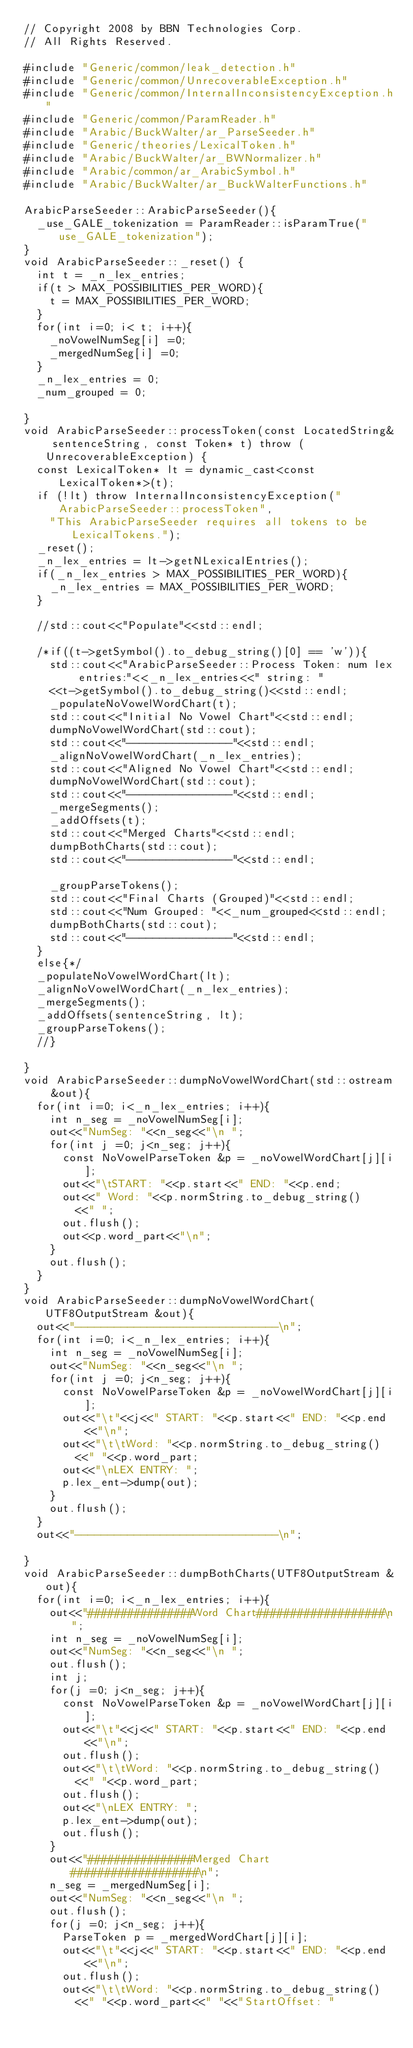<code> <loc_0><loc_0><loc_500><loc_500><_C++_>// Copyright 2008 by BBN Technologies Corp.
// All Rights Reserved.

#include "Generic/common/leak_detection.h"
#include "Generic/common/UnrecoverableException.h"
#include "Generic/common/InternalInconsistencyException.h"
#include "Generic/common/ParamReader.h"
#include "Arabic/BuckWalter/ar_ParseSeeder.h"
#include "Generic/theories/LexicalToken.h"
#include "Arabic/BuckWalter/ar_BWNormalizer.h"
#include "Arabic/common/ar_ArabicSymbol.h"
#include "Arabic/BuckWalter/ar_BuckWalterFunctions.h"

ArabicParseSeeder::ArabicParseSeeder(){
	_use_GALE_tokenization = ParamReader::isParamTrue("use_GALE_tokenization");
}
void ArabicParseSeeder::_reset() {
	int t = _n_lex_entries;
	if(t > MAX_POSSIBILITIES_PER_WORD){
		t = MAX_POSSIBILITIES_PER_WORD;
	}
	for(int i=0; i< t; i++){
		_noVowelNumSeg[i] =0;
		_mergedNumSeg[i] =0;
	}
	_n_lex_entries = 0;
	_num_grouped = 0;

}
void ArabicParseSeeder::processToken(const LocatedString& sentenceString, const Token* t) throw (UnrecoverableException) {
	const LexicalToken* lt = dynamic_cast<const LexicalToken*>(t);
	if (!lt) throw InternalInconsistencyException("ArabicParseSeeder::processToken", 
		"This ArabicParseSeeder requires all tokens to be LexicalTokens.");
	_reset();
	_n_lex_entries = lt->getNLexicalEntries();
	if(_n_lex_entries > MAX_POSSIBILITIES_PER_WORD){
		_n_lex_entries = MAX_POSSIBILITIES_PER_WORD;
	}

	//std::cout<<"Populate"<<std::endl;
	
	/*if((t->getSymbol().to_debug_string()[0] == 'w')){
		std::cout<<"ArabicParseSeeder::Process Token: num lex entries:"<<_n_lex_entries<<" string: "
		<<t->getSymbol().to_debug_string()<<std::endl;	
		_populateNoVowelWordChart(t);
		std::cout<<"Initial No Vowel Chart"<<std::endl;
		dumpNoVowelWordChart(std::cout);
		std::cout<<"----------------"<<std::endl;
		_alignNoVowelWordChart(_n_lex_entries);
		std::cout<<"Aligned No Vowel Chart"<<std::endl;
		dumpNoVowelWordChart(std::cout);
		std::cout<<"----------------"<<std::endl;
		_mergeSegments();
		_addOffsets(t);
		std::cout<<"Merged Charts"<<std::endl;
		dumpBothCharts(std::cout);
		std::cout<<"----------------"<<std::endl;

		_groupParseTokens();
		std::cout<<"Final Charts (Grouped)"<<std::endl;
		std::cout<<"Num Grouped: "<<_num_grouped<<std::endl;
		dumpBothCharts(std::cout);
		std::cout<<"----------------"<<std::endl;
	}
	else{*/
	_populateNoVowelWordChart(lt);
	_alignNoVowelWordChart(_n_lex_entries);
	_mergeSegments();
	_addOffsets(sentenceString, lt);
	_groupParseTokens();
	//}

}
void ArabicParseSeeder::dumpNoVowelWordChart(std::ostream &out){
	for(int i=0; i<_n_lex_entries; i++){
		int n_seg = _noVowelNumSeg[i];
		out<<"NumSeg: "<<n_seg<<"\n ";
		for(int j =0; j<n_seg; j++){
			const NoVowelParseToken &p = _noVowelWordChart[j][i];
			out<<"\tSTART: "<<p.start<<" END: "<<p.end;
			out<<" Word: "<<p.normString.to_debug_string()
				<<" ";
			out.flush();
			out<<p.word_part<<"\n";
		}
		out.flush();
	}
}
void ArabicParseSeeder::dumpNoVowelWordChart(UTF8OutputStream &out){
	out<<"-------------------------------\n";
	for(int i=0; i<_n_lex_entries; i++){
		int n_seg = _noVowelNumSeg[i];
		out<<"NumSeg: "<<n_seg<<"\n ";
		for(int j =0; j<n_seg; j++){
			const NoVowelParseToken &p = _noVowelWordChart[j][i];
			out<<"\t"<<j<<" START: "<<p.start<<" END: "<<p.end<<"\n";
			out<<"\t\tWord: "<<p.normString.to_debug_string()
				<<" "<<p.word_part;
			out<<"\nLEX ENTRY: ";
			p.lex_ent->dump(out);
		}
		out.flush();
	}
	out<<"-------------------------------\n";

}
void ArabicParseSeeder::dumpBothCharts(UTF8OutputStream &out){
	for(int i=0; i<_n_lex_entries; i++){
		out<<"################Word Chart###################\n";
		int n_seg = _noVowelNumSeg[i];
		out<<"NumSeg: "<<n_seg<<"\n ";
		out.flush();
		int j;
		for(j =0; j<n_seg; j++){
			const NoVowelParseToken &p = _noVowelWordChart[j][i];
			out<<"\t"<<j<<" START: "<<p.start<<" END: "<<p.end<<"\n";
			out.flush();
			out<<"\t\tWord: "<<p.normString.to_debug_string()
				<<" "<<p.word_part;
			out.flush();
			out<<"\nLEX ENTRY: ";
			p.lex_ent->dump(out);
			out.flush();
		}
		out<<"################Merged Chart###################\n";
		n_seg = _mergedNumSeg[i];
		out<<"NumSeg: "<<n_seg<<"\n ";
		out.flush();
		for(j =0; j<n_seg; j++){
			ParseToken p = _mergedWordChart[j][i];
			out<<"\t"<<j<<" START: "<<p.start<<" END: "<<p.end<<"\n";
			out.flush();
			out<<"\t\tWord: "<<p.normString.to_debug_string()
				<<" "<<p.word_part<<" "<<"StartOffset: "</code> 